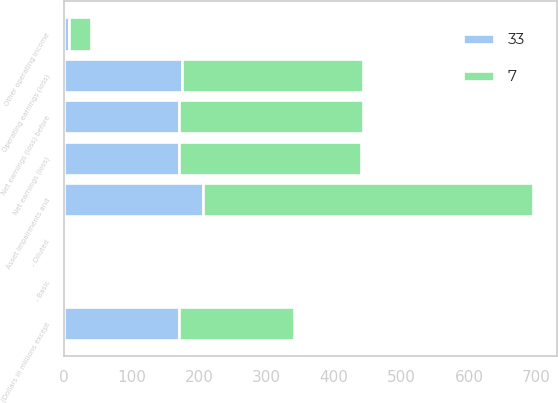<chart> <loc_0><loc_0><loc_500><loc_500><stacked_bar_chart><ecel><fcel>(Dollars in millions except<fcel>Operating earnings (loss)<fcel>Net earnings (loss) before<fcel>Net earnings (loss)<fcel>- Basic<fcel>- Diluted<fcel>Asset impairments and<fcel>Other operating income<nl><fcel>33<fcel>170<fcel>175<fcel>170<fcel>170<fcel>2.2<fcel>2.18<fcel>206<fcel>7<nl><fcel>7<fcel>170<fcel>267<fcel>273<fcel>270<fcel>3.5<fcel>3.5<fcel>489<fcel>33<nl></chart> 